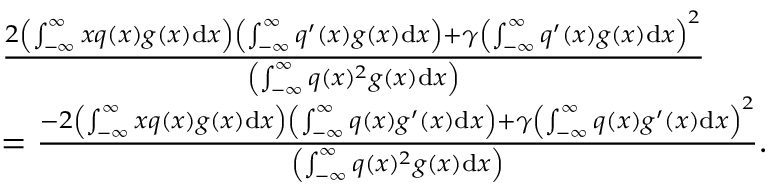Convert formula to latex. <formula><loc_0><loc_0><loc_500><loc_500>\begin{array} { r l } & { \frac { 2 \left ( \int _ { - \infty } ^ { \infty } x q ( x ) g ( x ) d x \right ) \left ( \int _ { - \infty } ^ { \infty } q ^ { \prime } ( x ) g ( x ) d x \right ) + \gamma \left ( \int _ { - \infty } ^ { \infty } q ^ { \prime } ( x ) g ( x ) d x \right ) ^ { 2 } } { \left ( \int _ { - \infty } ^ { \infty } q ( x ) ^ { 2 } g ( x ) d x \right ) } } \\ & { = \frac { - 2 \left ( \int _ { - \infty } ^ { \infty } x q ( x ) g ( x ) d x \right ) \left ( \int _ { - \infty } ^ { \infty } q ( x ) g ^ { \prime } ( x ) d x \right ) + \gamma \left ( \int _ { - \infty } ^ { \infty } q ( x ) g ^ { \prime } ( x ) d x \right ) ^ { 2 } } { \left ( \int _ { - \infty } ^ { \infty } q ( x ) ^ { 2 } g ( x ) d x \right ) } . } \end{array}</formula> 